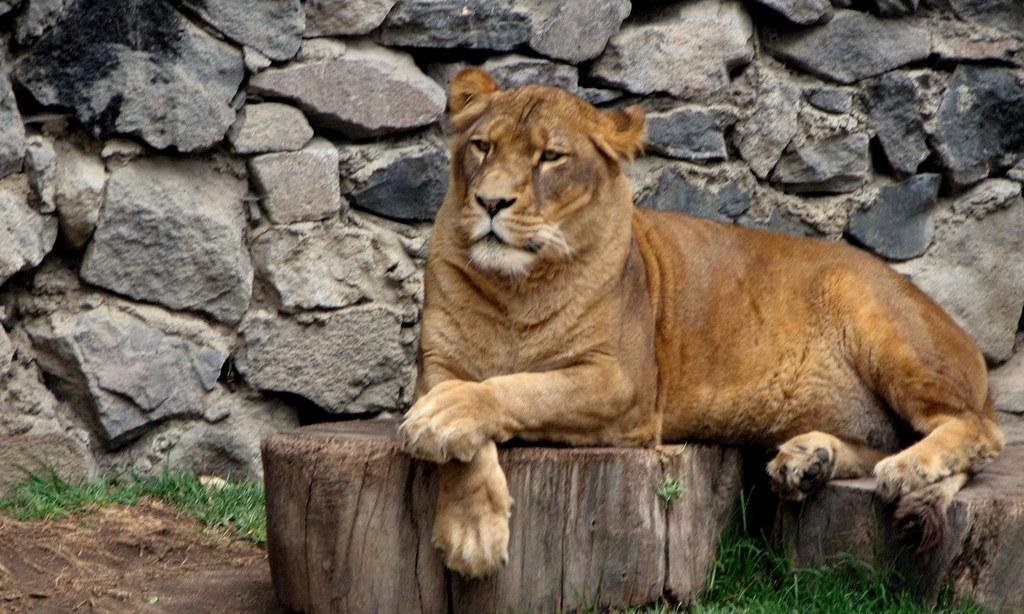What type of animal is in the image? The type of animal cannot be determined from the provided facts. What is the animal standing on or interacting with in the image? The animal is on a wooden object in the image. What type of vegetation is visible in the image? There is grass in the image. What can be seen in the background of the image? There is a stone wall in the background of the image. What type of instrument is the animal playing in the image? There is no instrument present in the image, and the animal is not shown playing any instrument. 